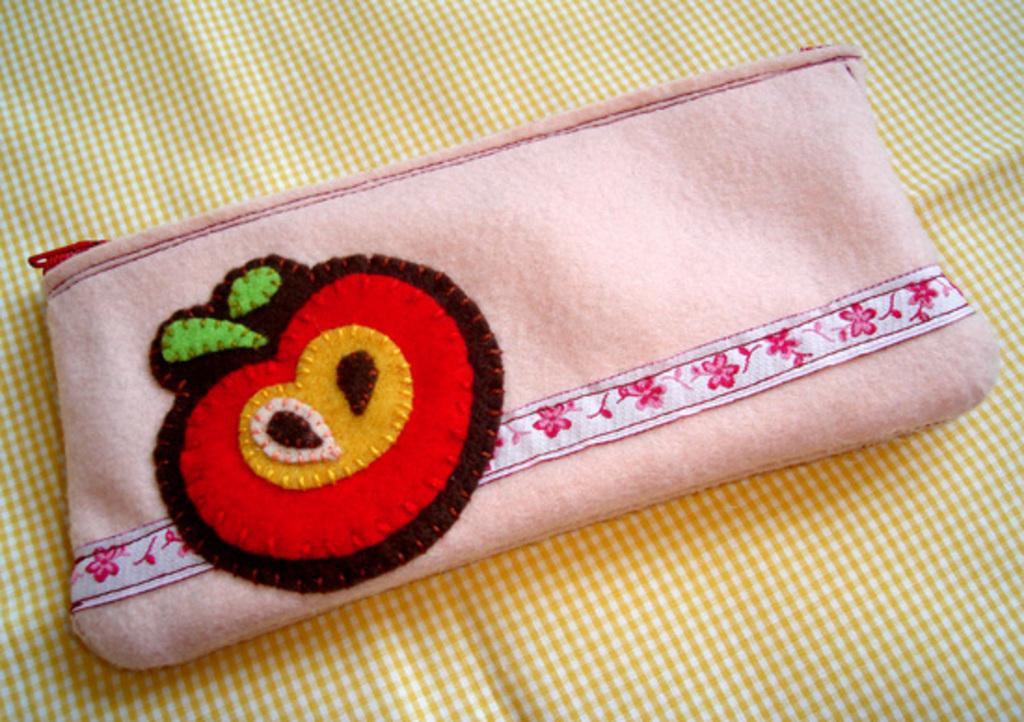What object is placed on the bed in the image? There is a pouch on the bed. Can you describe the setting of the image? The image is likely taken in a room. What type of bridge can be seen in the image? There is no bridge present in the image; it features a pouch on a bed in a room. 